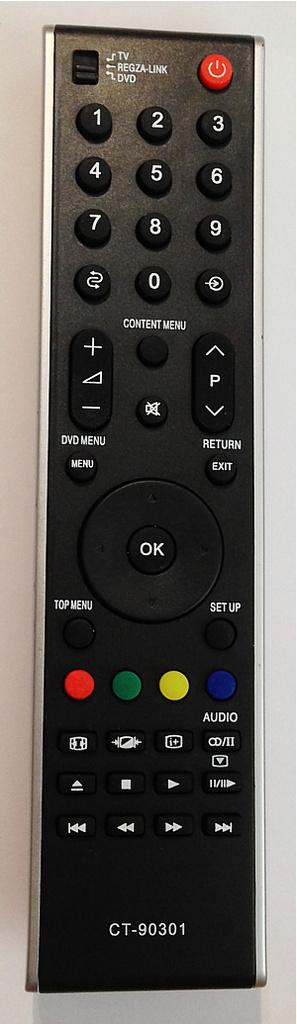Provide a one-sentence caption for the provided image. A television remote with the code CT-90301 written on the bottom. 